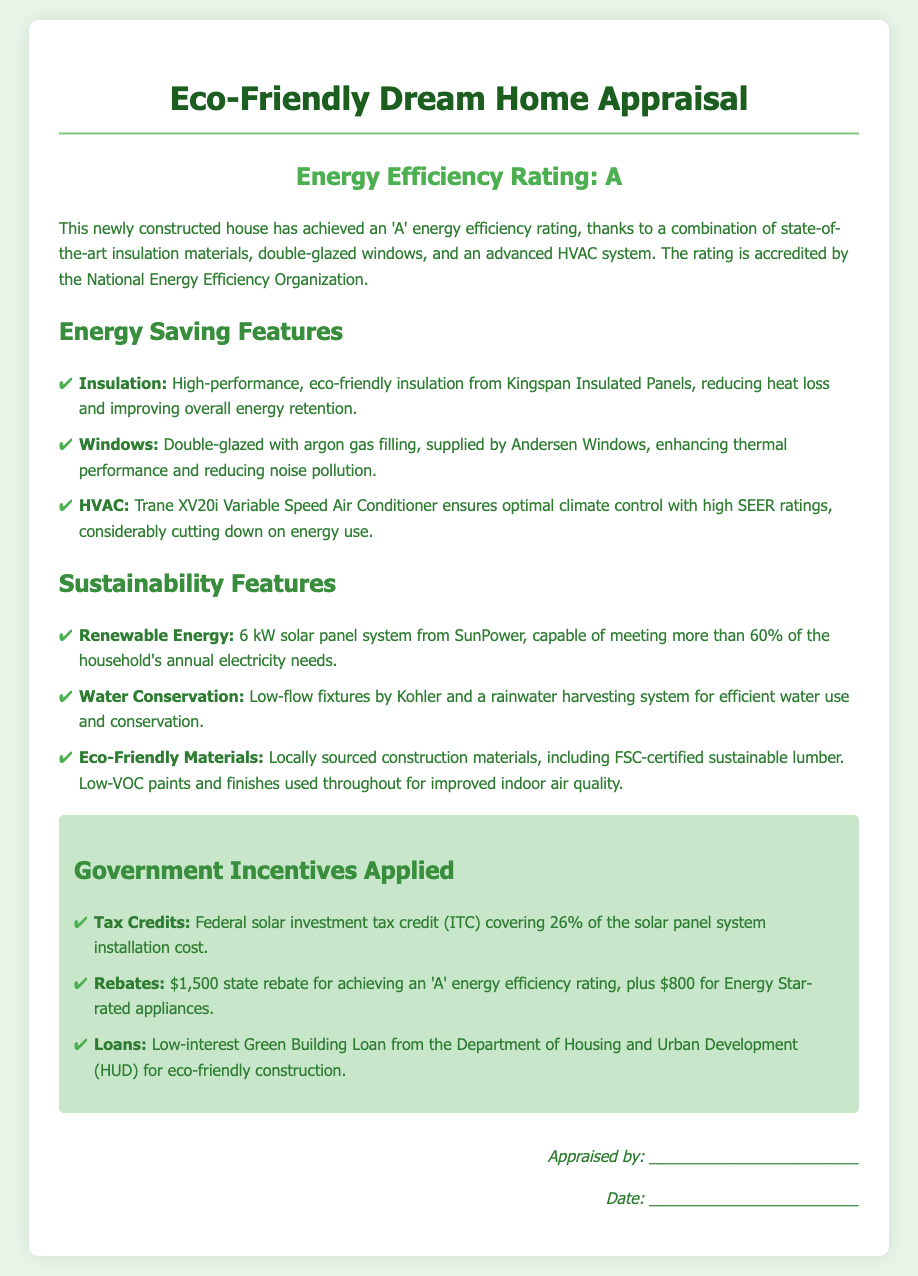what is the energy efficiency rating of the house? The house has achieved an 'A' energy efficiency rating as stated in the document.
Answer: A who supplied the double-glazed windows? The double-glazed windows were supplied by Andersen Windows according to the document.
Answer: Andersen Windows what percentage of the household's annual electricity needs is met by the solar panel system? The document states that the solar panel system meets more than 60% of the household's annual electricity needs.
Answer: more than 60% what is the value of the state rebate for achieving an 'A' energy efficiency rating? According to the document, the state rebate for achieving an 'A' energy efficiency rating is $1,500.
Answer: $1,500 what type of air conditioner is installed in the house? The installed air conditioner is a Trane XV20i Variable Speed Air Conditioner as mentioned in the document.
Answer: Trane XV20i Variable Speed Air Conditioner how much is covered by the federal solar investment tax credit? The federal solar investment tax credit (ITC) covers 26% of the solar panel system installation cost.
Answer: 26% which agency provides the Green Building Loan? The Green Building Loan is provided by the Department of Housing and Urban Development (HUD) as per the document.
Answer: Department of Housing and Urban Development what construction materials are mentioned as eco-friendly? The document mentions locally sourced construction materials and FSC-certified sustainable lumber as eco-friendly.
Answer: locally sourced construction materials, FSC-certified sustainable lumber 